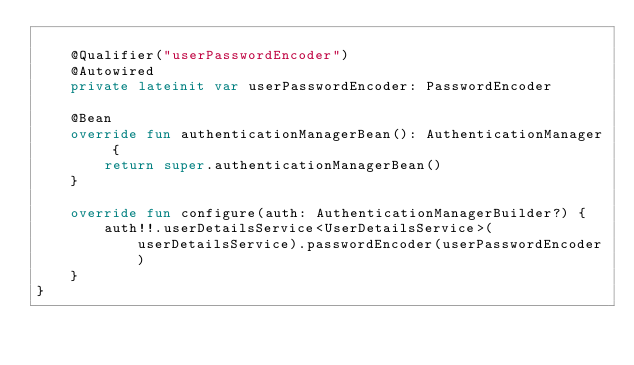Convert code to text. <code><loc_0><loc_0><loc_500><loc_500><_Kotlin_>
    @Qualifier("userPasswordEncoder")
    @Autowired
    private lateinit var userPasswordEncoder: PasswordEncoder

    @Bean
    override fun authenticationManagerBean(): AuthenticationManager {
        return super.authenticationManagerBean()
    }

    override fun configure(auth: AuthenticationManagerBuilder?) {
        auth!!.userDetailsService<UserDetailsService>(userDetailsService).passwordEncoder(userPasswordEncoder)
    }
}
</code> 